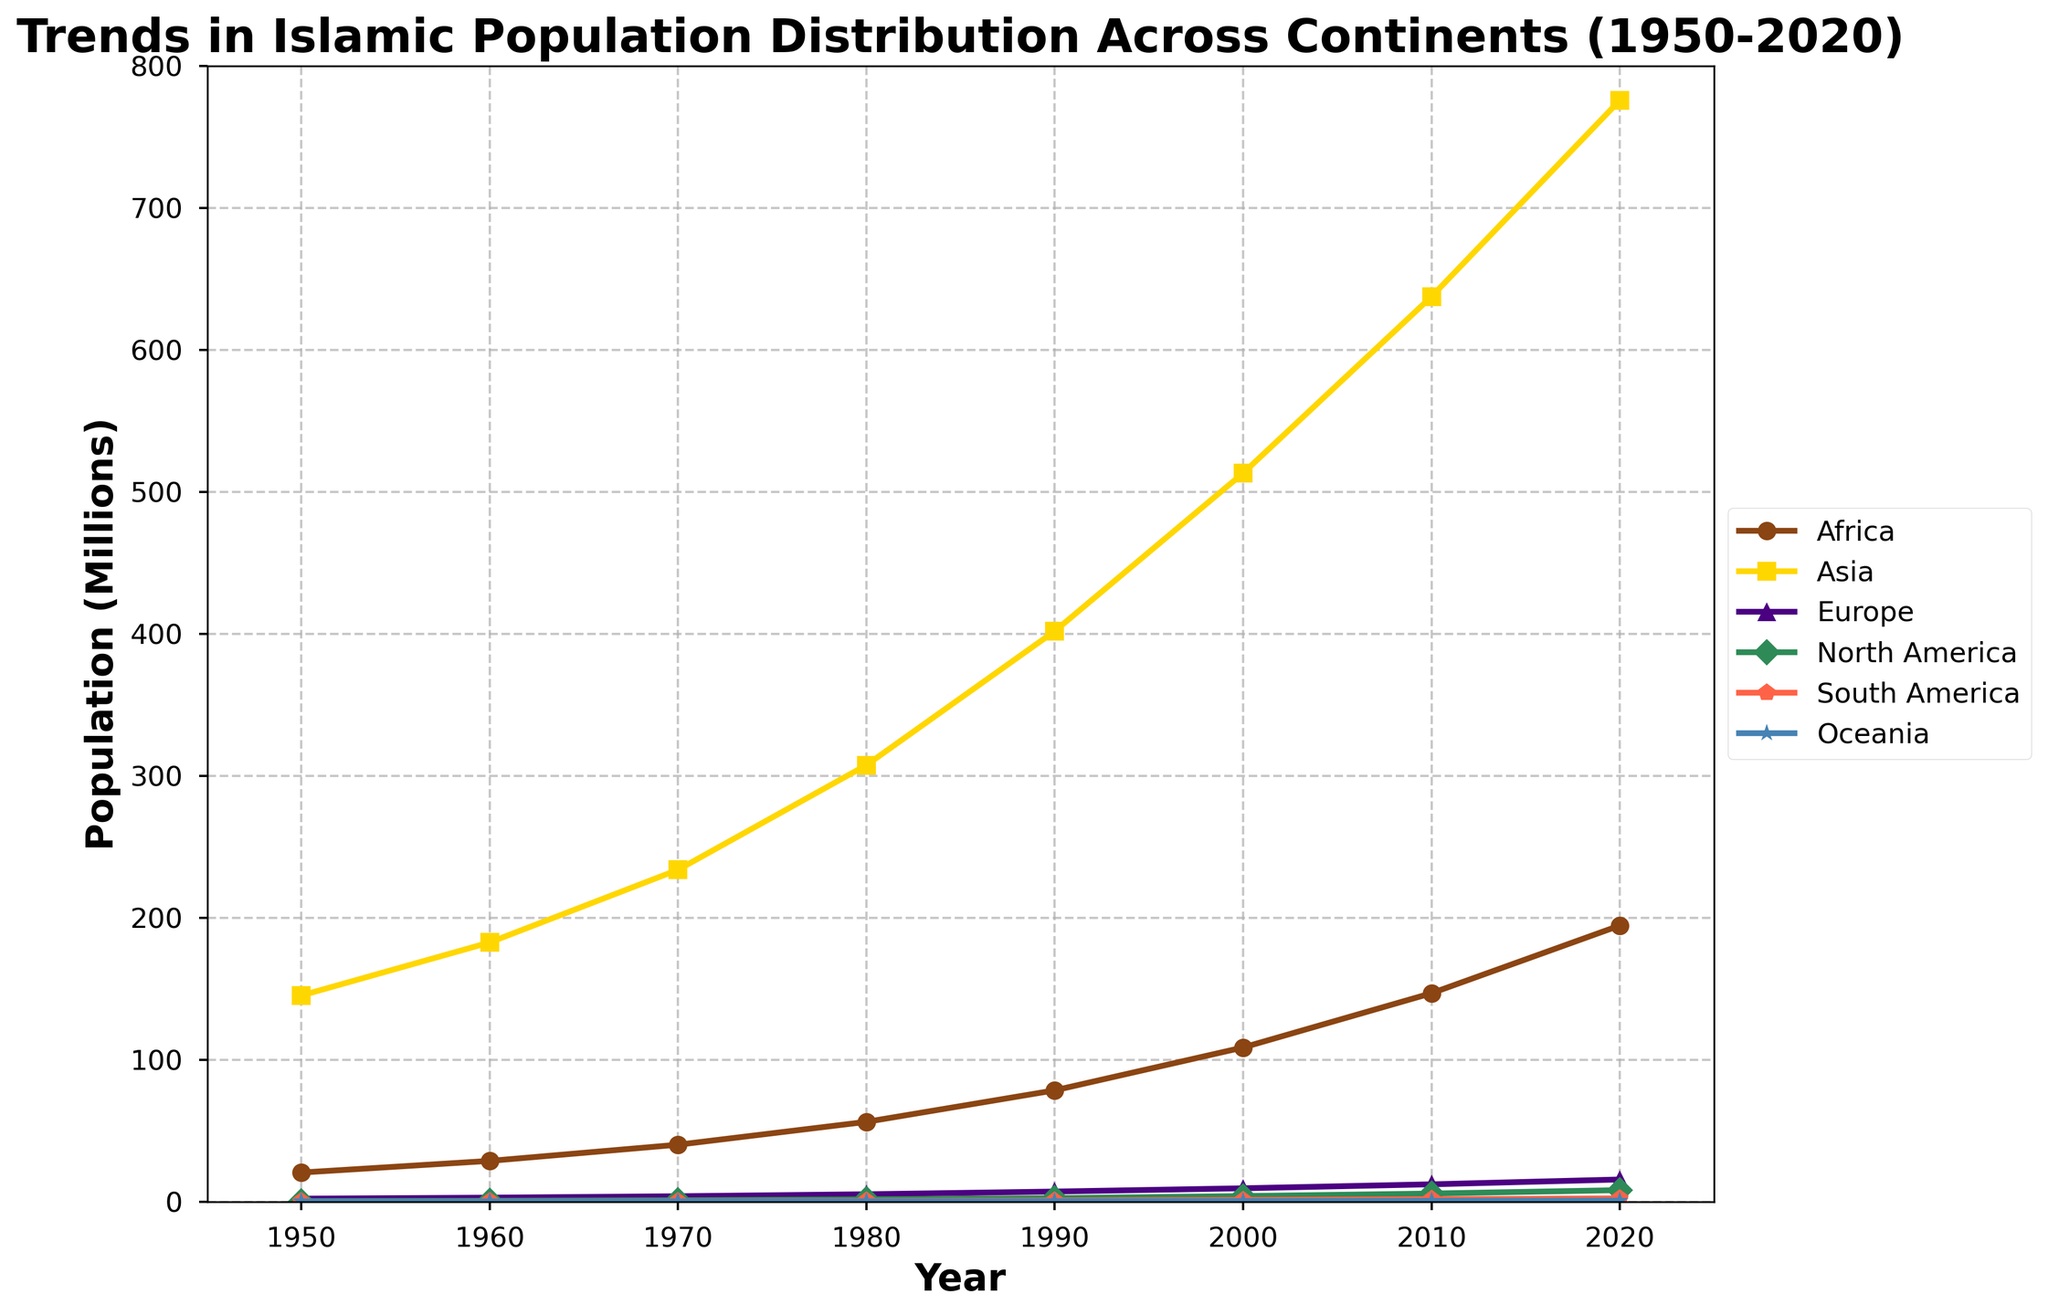Which continent saw the highest increase in Islamic population between 1950 and 2020? To determine the highest increase, subtract the Islamic population in 1950 from the population in 2020 for each continent. Africa: 194.5 - 20.5 = 174, Asia: 775.8 - 145.2 = 630.6, Europe: 15.6 - 2.1 = 13.5, North America: 8.1 - 0.4 = 7.7, South America: 2.3 - 0.1 = 2.2, Oceania: 0.7 - 0.1 = 0.6. Asia has the highest increase.
Answer: Asia Which two continents had nearly parallel trends in Islamic population growth over the period from 1950 to 2020? Looking at the slopes of the lines on the graph, Asia and Africa have nearly parallel trends, indicating similar rates of growth over the period.
Answer: Asia and Africa What is the combined Islamic population of Europe and North America in 2020? The figures for 2020 are Europe: 15.6 million and North America: 8.1 million. Adding these together gives 15.6 + 8.1 = 23.7 million.
Answer: 23.7 million Which continent experienced the smallest growth in Islamic population between 1950 and 2020? To find the smallest growth, compare the differences in populations from 1950 to 2020 for each continent: Africa: 174, Asia: 630.6, Europe: 13.5, North America: 7.7, South America: 2.2, Oceania: 0.6. Oceania has the smallest growth.
Answer: Oceania In 2000, which continents had similar Islamic population sizes? In 2000, South America had an Islamic population of 1.2 million and Oceania had 0.4 million. Europe had 9.4 million and North America had 3.9 million. North America and South America have the most similar values among them, but they are not very close. No pair of continents had very similar populations in 2000.
Answer: None How did the Islamic population of Africa compare to that of South America in 1990? In 1990, Africa's Islamic population was 78.4 million, and South America's was 0.8 million. Africa's population was therefore much greater than South America's.
Answer: Much greater By how much did the Islamic population in Oceania increase from 1950 to 1980? Subtract the 1950 population from the 1980 population for Oceania: 0.2 - 0.1 = 0.1 million.
Answer: 0.1 million What was the approximate average annual growth rate in the Islamic population of Asia from 1950 to 2020? To calculate the average annual growth rate, find the total increase (775.8 - 145.2 = 630.6 million) and divide by the number of years (2020 - 1950 = 70 years): 630.6 / 70 ≈ 9.01 million per year.
Answer: 9.01 million per year How does the Islamic population growth in North America compare to that in Europe from 1950 to 2020? For North America: 8.1 - 0.4 = 7.7 million. For Europe: 15.6 - 2.1 = 13.5 million. Europe had a larger increase in Islamic population than North America.
Answer: Europe had a larger increase What years saw the Islamic population in Asia surpass 500 million? From the dataset, the Islamic population in Asia surpassed 500 million between 1990 and 2000 (1990: 401.9 million, 2000: 513.2 million). Therefore, it was in the 1990s.
Answer: 1990s 